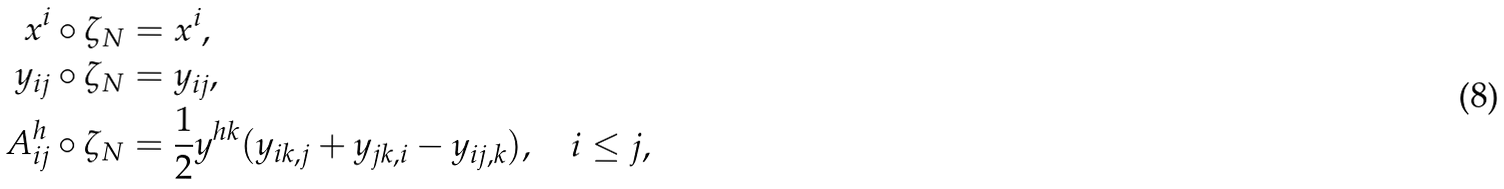Convert formula to latex. <formula><loc_0><loc_0><loc_500><loc_500>x ^ { i } \circ \zeta _ { N } & = x ^ { i } , \\ y _ { i j } \circ \zeta _ { N } & = y _ { i j } , \\ A _ { i j } ^ { h } \circ \zeta _ { N } & = \frac { 1 } { 2 } y ^ { h k } ( y _ { i k , j } + y _ { j k , i } - y _ { i j , k } ) , \quad i \leq j ,</formula> 